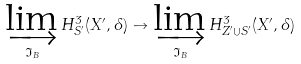<formula> <loc_0><loc_0><loc_500><loc_500>\varinjlim _ { \mathfrak { I } _ { B } } H ^ { 3 } _ { S ^ { \prime } } ( X ^ { \prime } , \Lambda ) \to \varinjlim _ { \mathfrak { I } _ { B } } H ^ { 3 } _ { Z ^ { \prime } \cup S ^ { \prime } } ( X ^ { \prime } , \Lambda )</formula> 